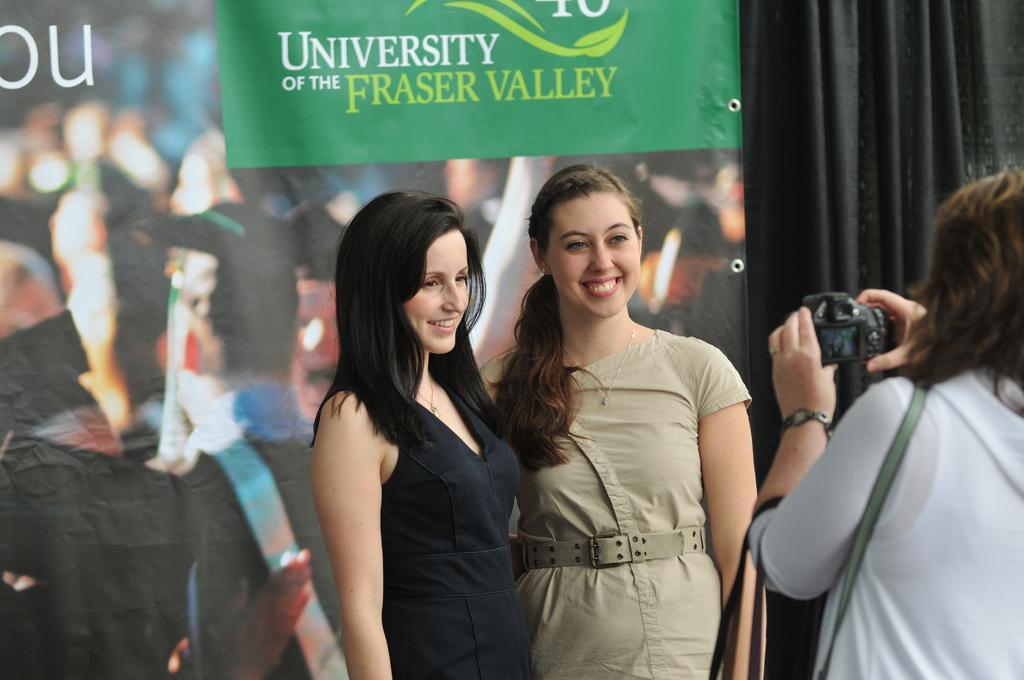Please provide a concise description of this image. in this image I can see few women are standing and I can see she is holding a camera. I can also see smile on few faces and in the background I can see something is written. 